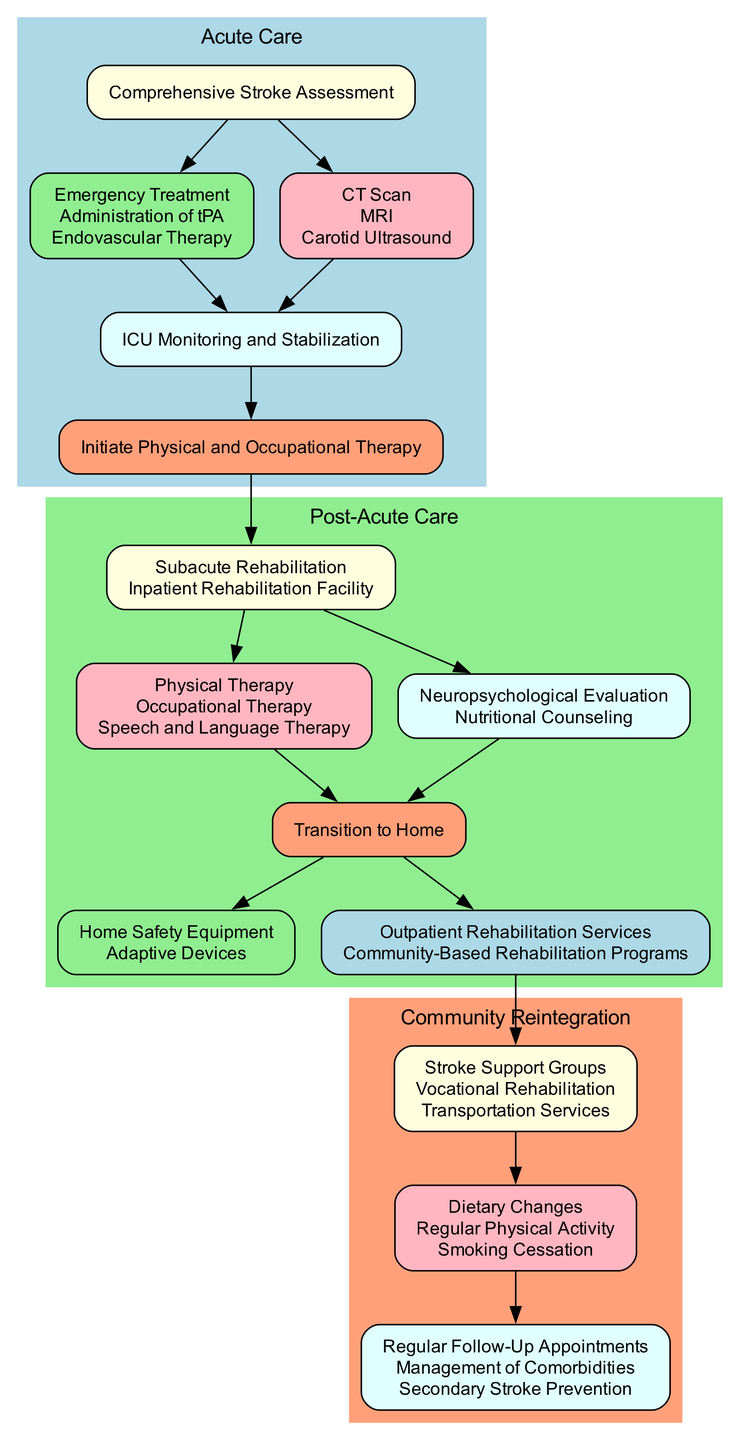What is the first step in the Acute Care phase? The first step listed in the Acute Care phase is "Comprehensive Stroke Assessment." This is the initial action taken to evaluate the patient after a stroke.
Answer: Comprehensive Stroke Assessment How many interventions are listed in the Acute Care section? There are three interventions listed in the Acute Care section: "Emergency Treatment," "Administration of tPA," and "Endovascular Therapy." By counting these listed items, we find the total.
Answer: 3 What type of therapy is included in the Subacute Rehabilitation? The therapies listed in Subacute Rehabilitation include "Physical Therapy," "Occupational Therapy," and "Speech and Language Therapy." Any of these types can be considered, but they are all related.
Answer: Physical Therapy What is the relationship between Early Rehabilitation and Subacute Rehabilitation? The relationship is that Early Rehabilitation leads to Subacute Rehabilitation, indicating a flow from one phase to the next in the treatment process. The diagram shows this by connecting these two nodes with an edge.
Answer: Early Rehabilitation leads to Subacute Rehabilitation What additional services are provided in the Subacute Rehabilitation phase? The additional services provided in this phase are "Neuropsychological Evaluation" and "Nutritional Counseling." These services support the therapies during rehabilitation.
Answer: Neuropsychological Evaluation, Nutritional Counseling What kind of support services are available during Community Reintegration? The support services available during Community Reintegration include "Stroke Support Groups," "Vocational Rehabilitation," and "Transportation Services." Each of these services aids in the reintegration of the patient into the community.
Answer: Stroke Support Groups What equipment is necessary for the transition to home? The equipment necessary for the transition to home includes "Home Safety Equipment" and "Adaptive Devices." Both types of equipment assist in making the home environment safer and more accommodating for recovery.
Answer: Home Safety Equipment, Adaptive Devices How is Community Reintegration connected to Long Term Care? Community Reintegration is connected to Long Term Care through the flow of services and follow-up care, as shown in the diagram. After engaging with support services, there is a progression toward long-term management, denoting that community support is vital for ongoing care.
Answer: Support Services lead to Long Term Care What is the last phase in the rehabilitation pathway? The last phase in the rehabilitation pathway is "Community Reintegration." This indicates the final step where patients return to their regular community life, completing the pathway.
Answer: Community Reintegration 